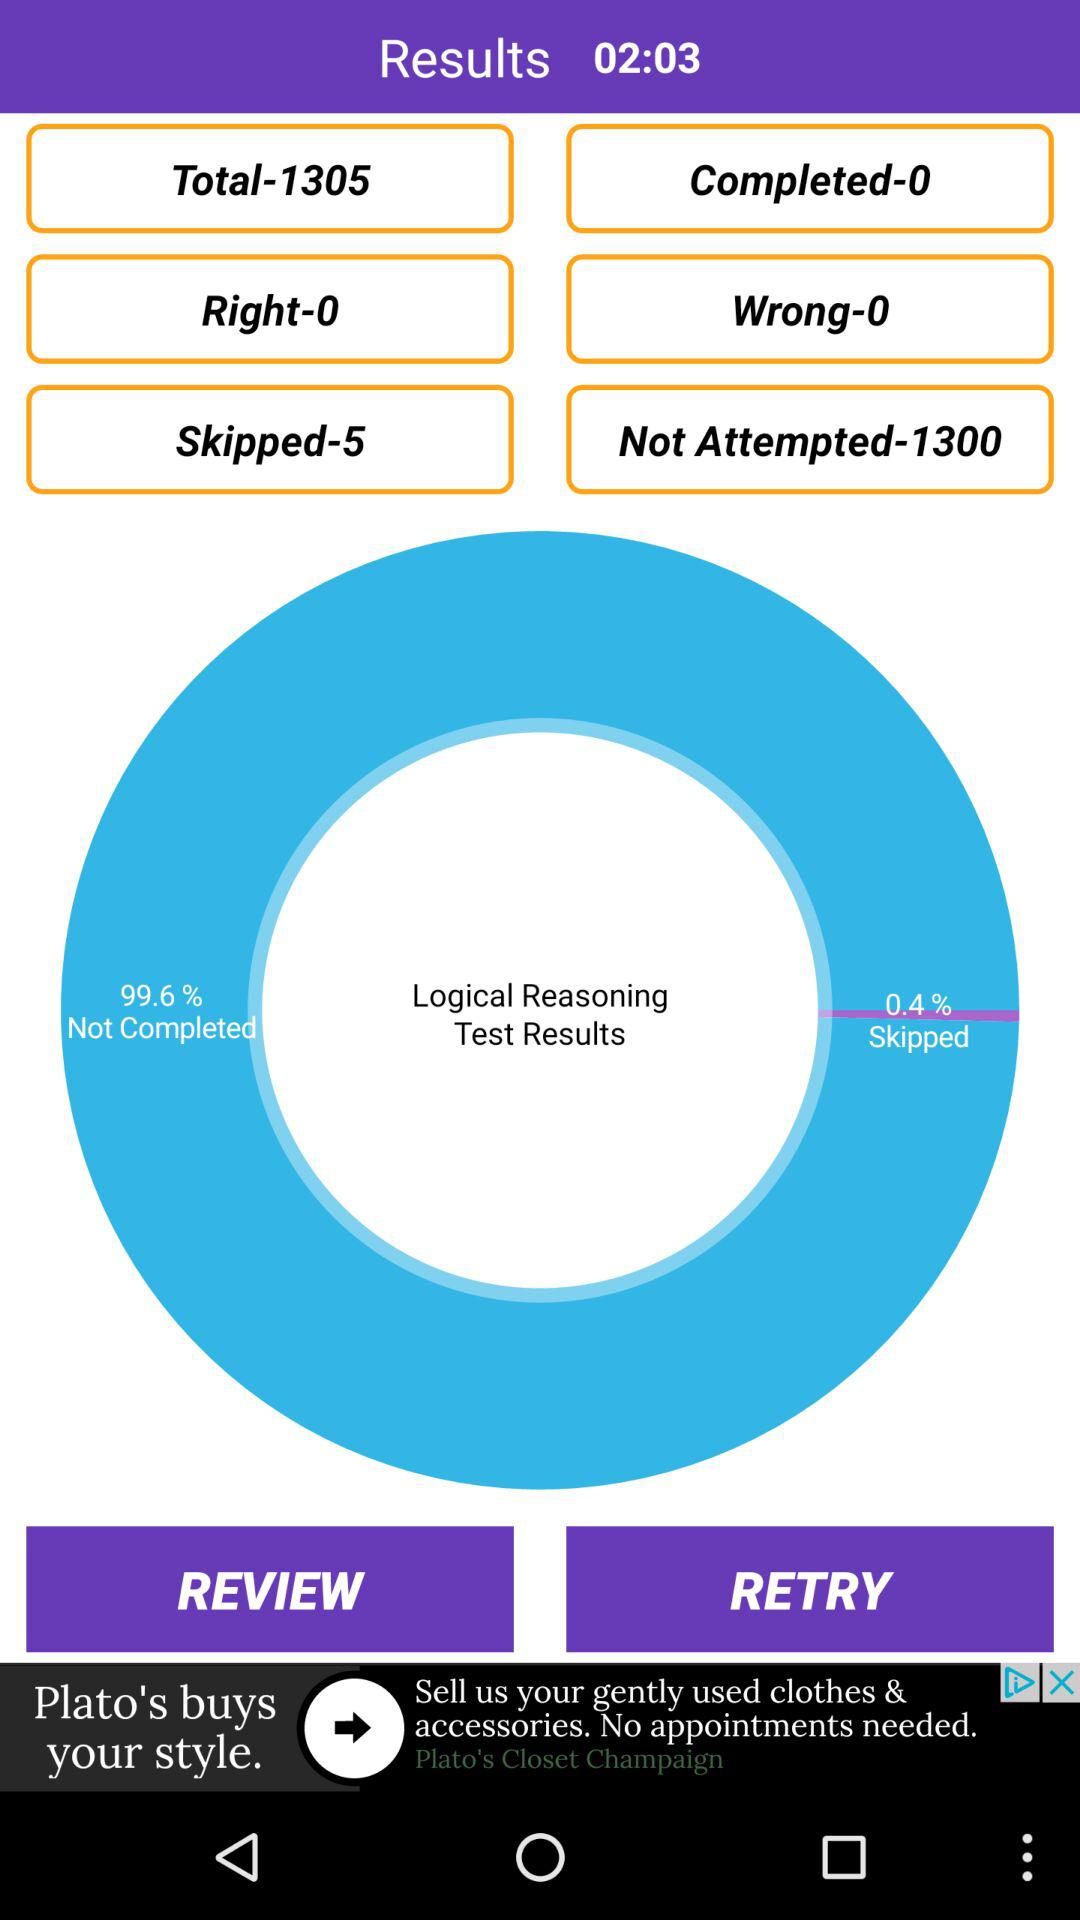What is the count of "Not Attempted" questions? The count of "Not Attempted" questions is 1300. 